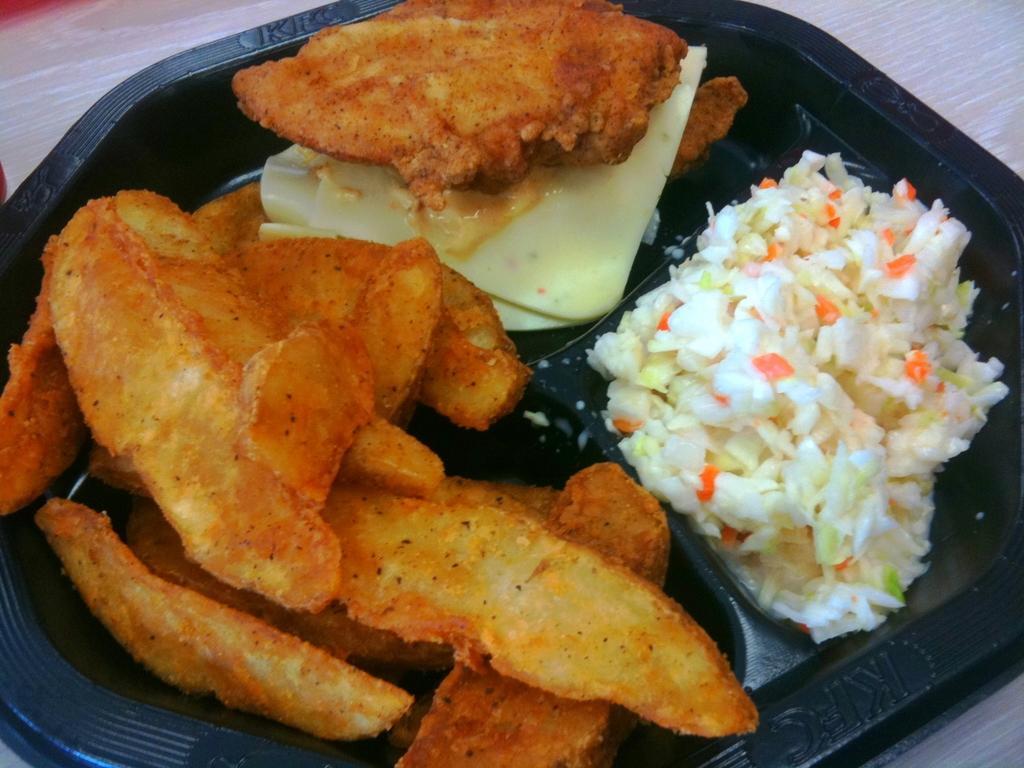Describe this image in one or two sentences. In this image we can see some food in a plate which is placed on the surface. 